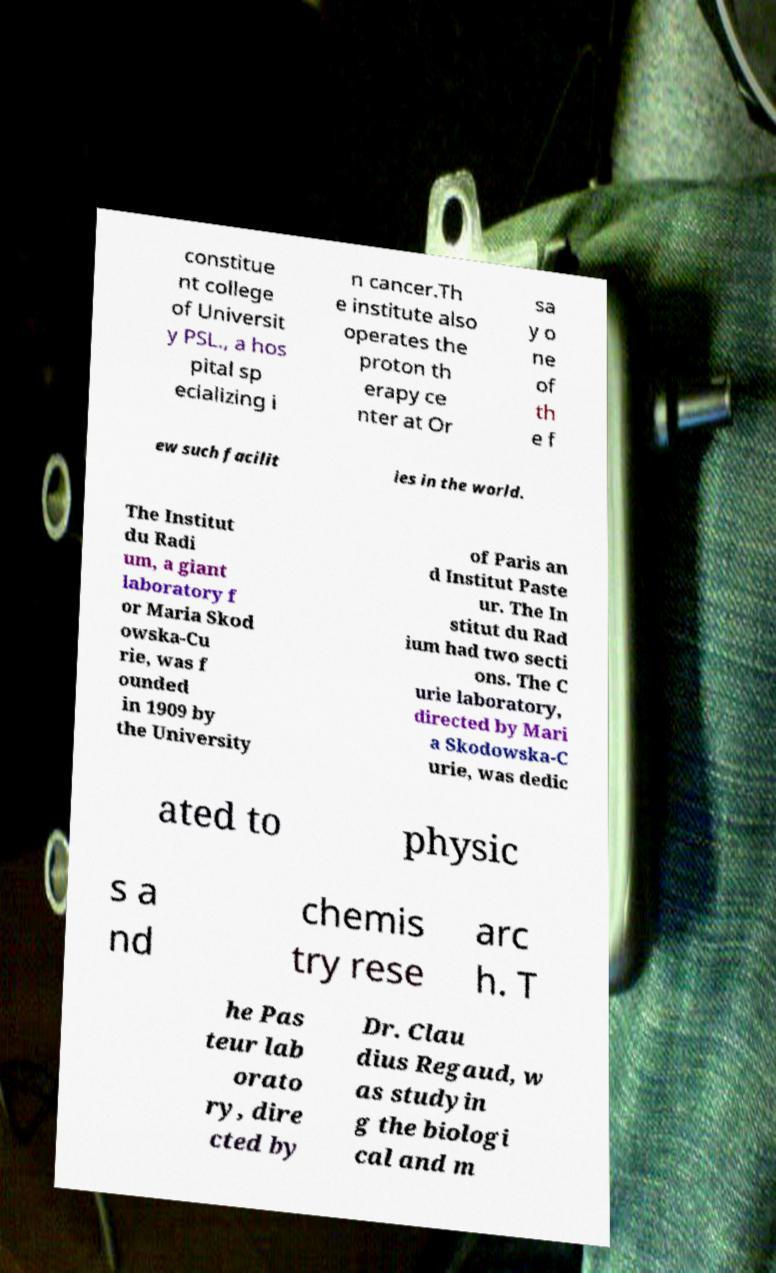Please read and relay the text visible in this image. What does it say? constitue nt college of Universit y PSL., a hos pital sp ecializing i n cancer.Th e institute also operates the proton th erapy ce nter at Or sa y o ne of th e f ew such facilit ies in the world. The Institut du Radi um, a giant laboratory f or Maria Skod owska-Cu rie, was f ounded in 1909 by the University of Paris an d Institut Paste ur. The In stitut du Rad ium had two secti ons. The C urie laboratory, directed by Mari a Skodowska-C urie, was dedic ated to physic s a nd chemis try rese arc h. T he Pas teur lab orato ry, dire cted by Dr. Clau dius Regaud, w as studyin g the biologi cal and m 